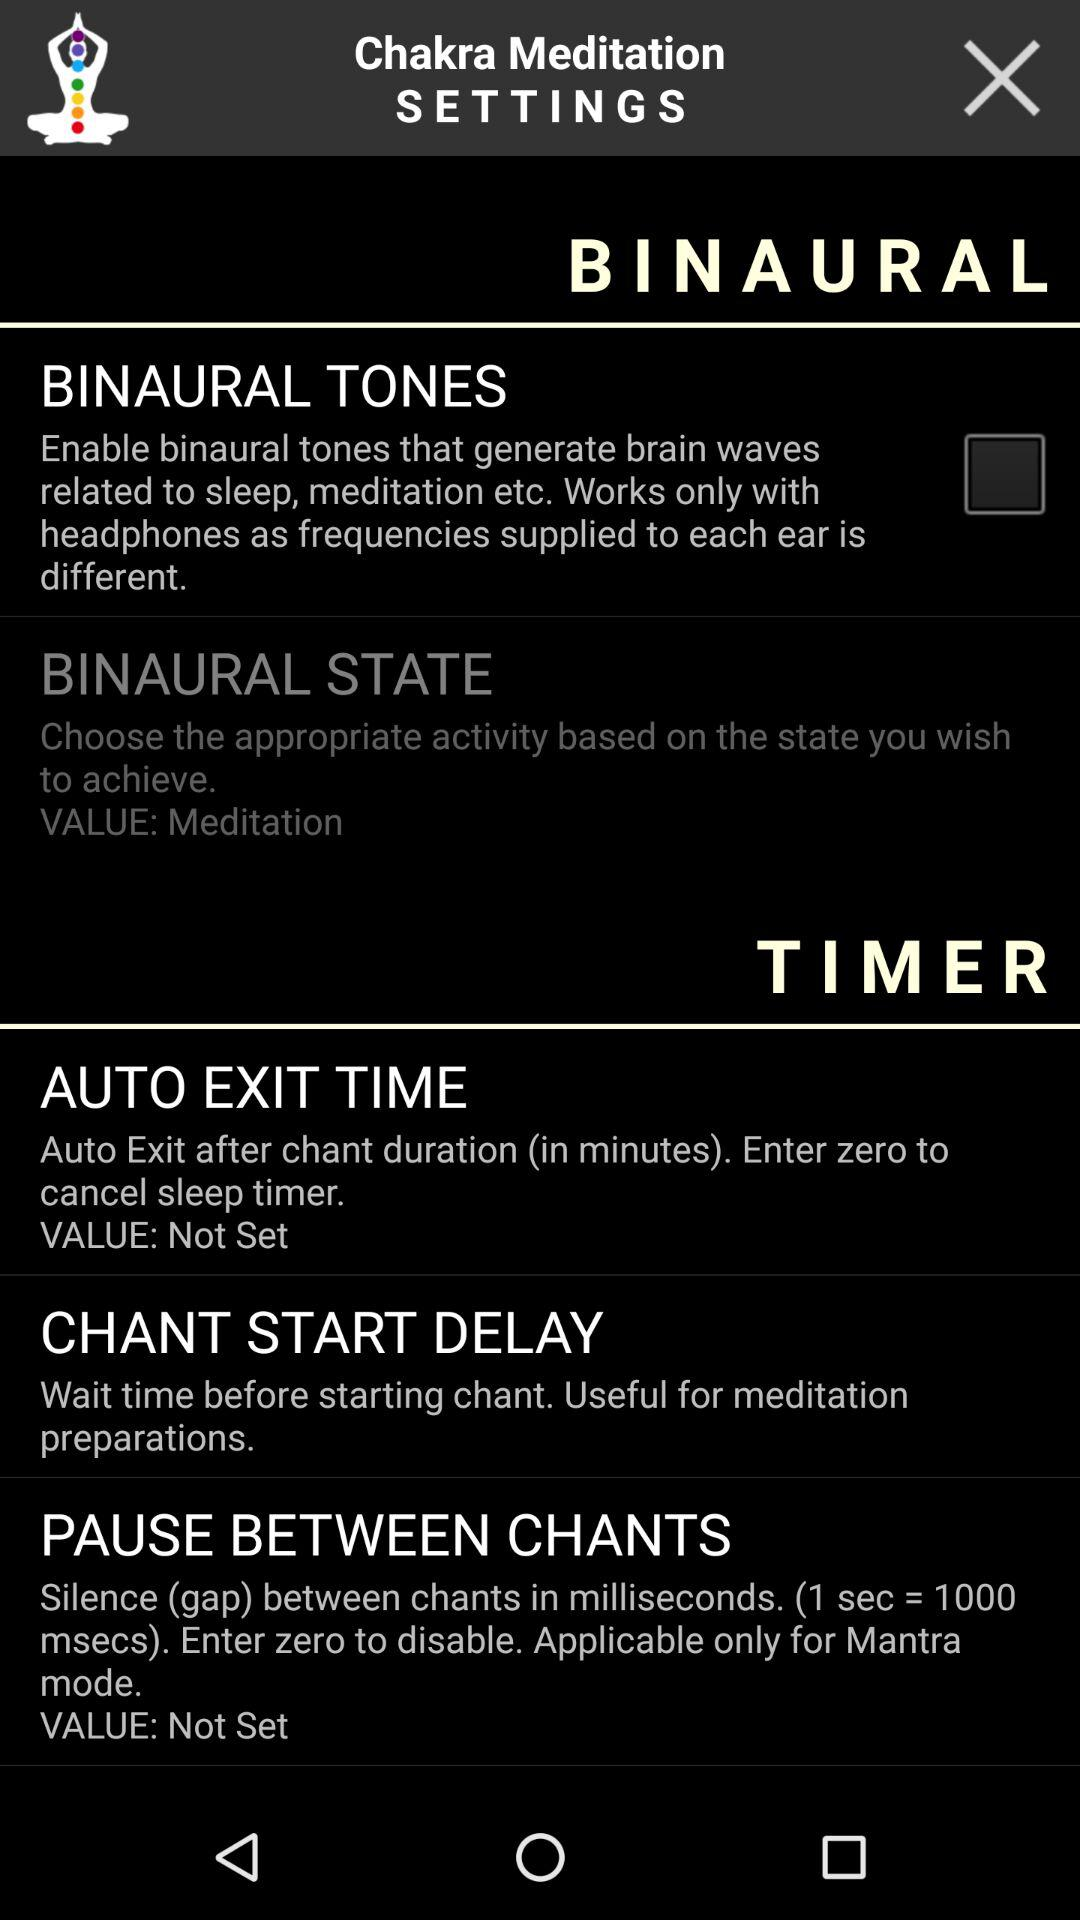What is the time duration for the silence gap in mantra mode? The time duration is 1 second. 